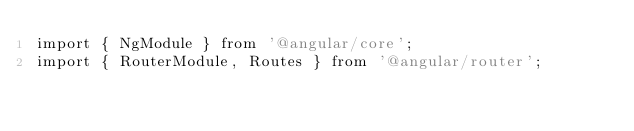Convert code to text. <code><loc_0><loc_0><loc_500><loc_500><_TypeScript_>import { NgModule } from '@angular/core';
import { RouterModule, Routes } from '@angular/router';</code> 